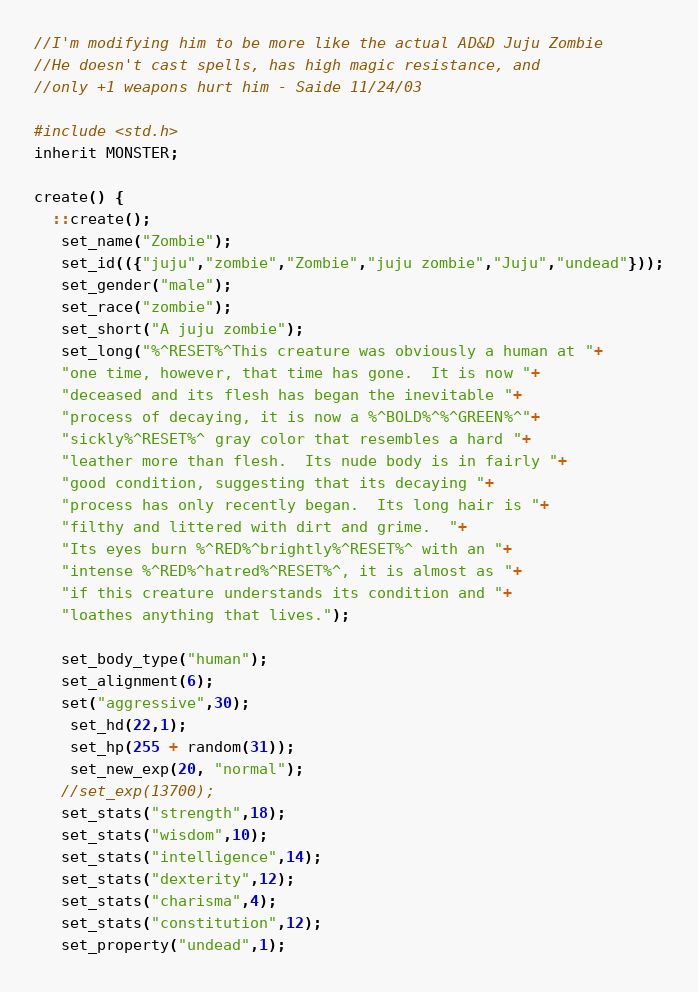Convert code to text. <code><loc_0><loc_0><loc_500><loc_500><_C_>//I'm modifying him to be more like the actual AD&D Juju Zombie 
//He doesn't cast spells, has high magic resistance, and 
//only +1 weapons hurt him - Saide 11/24/03

#include <std.h>
inherit MONSTER;

create() {
  ::create();
   set_name("Zombie");
   set_id(({"juju","zombie","Zombie","juju zombie","Juju","undead"}));
   set_gender("male");
   set_race("zombie");
   set_short("A juju zombie");
   set_long("%^RESET%^This creature was obviously a human at "+
   "one time, however, that time has gone.  It is now "+
   "deceased and its flesh has began the inevitable "+
   "process of decaying, it is now a %^BOLD%^%^GREEN%^"+
   "sickly%^RESET%^ gray color that resembles a hard "+
   "leather more than flesh.  Its nude body is in fairly "+
   "good condition, suggesting that its decaying "+
   "process has only recently began.  Its long hair is "+
   "filthy and littered with dirt and grime.  "+
   "Its eyes burn %^RED%^brightly%^RESET%^ with an "+
   "intense %^RED%^hatred%^RESET%^, it is almost as "+
   "if this creature understands its condition and "+
   "loathes anything that lives.");
   
   set_body_type("human");
   set_alignment(6);
   set("aggressive",30);
   	set_hd(22,1);
   	set_hp(255 + random(31));
	set_new_exp(20, "normal");
   //set_exp(13700);
   set_stats("strength",18);
   set_stats("wisdom",10);
   set_stats("intelligence",14);
   set_stats("dexterity",12);
   set_stats("charisma",4);
   set_stats("constitution",12);
   set_property("undead",1);</code> 